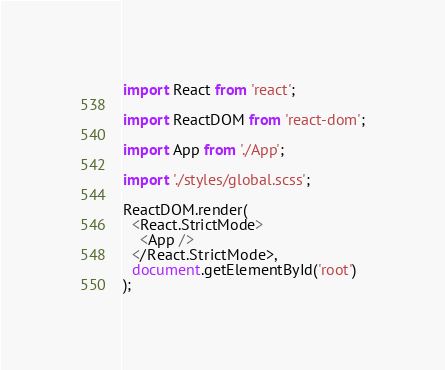<code> <loc_0><loc_0><loc_500><loc_500><_TypeScript_>import React from 'react';

import ReactDOM from 'react-dom';

import App from './App';

import './styles/global.scss';

ReactDOM.render(
  <React.StrictMode>
    <App />
  </React.StrictMode>,
  document.getElementById('root')
);</code> 